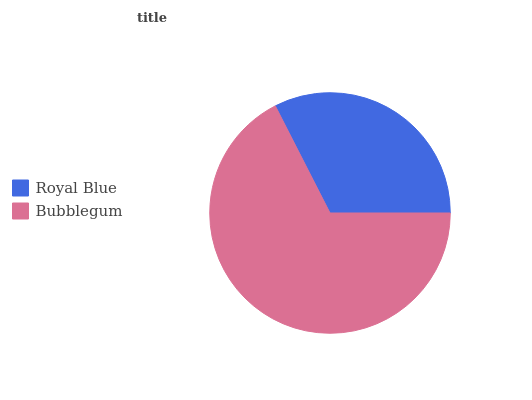Is Royal Blue the minimum?
Answer yes or no. Yes. Is Bubblegum the maximum?
Answer yes or no. Yes. Is Bubblegum the minimum?
Answer yes or no. No. Is Bubblegum greater than Royal Blue?
Answer yes or no. Yes. Is Royal Blue less than Bubblegum?
Answer yes or no. Yes. Is Royal Blue greater than Bubblegum?
Answer yes or no. No. Is Bubblegum less than Royal Blue?
Answer yes or no. No. Is Bubblegum the high median?
Answer yes or no. Yes. Is Royal Blue the low median?
Answer yes or no. Yes. Is Royal Blue the high median?
Answer yes or no. No. Is Bubblegum the low median?
Answer yes or no. No. 